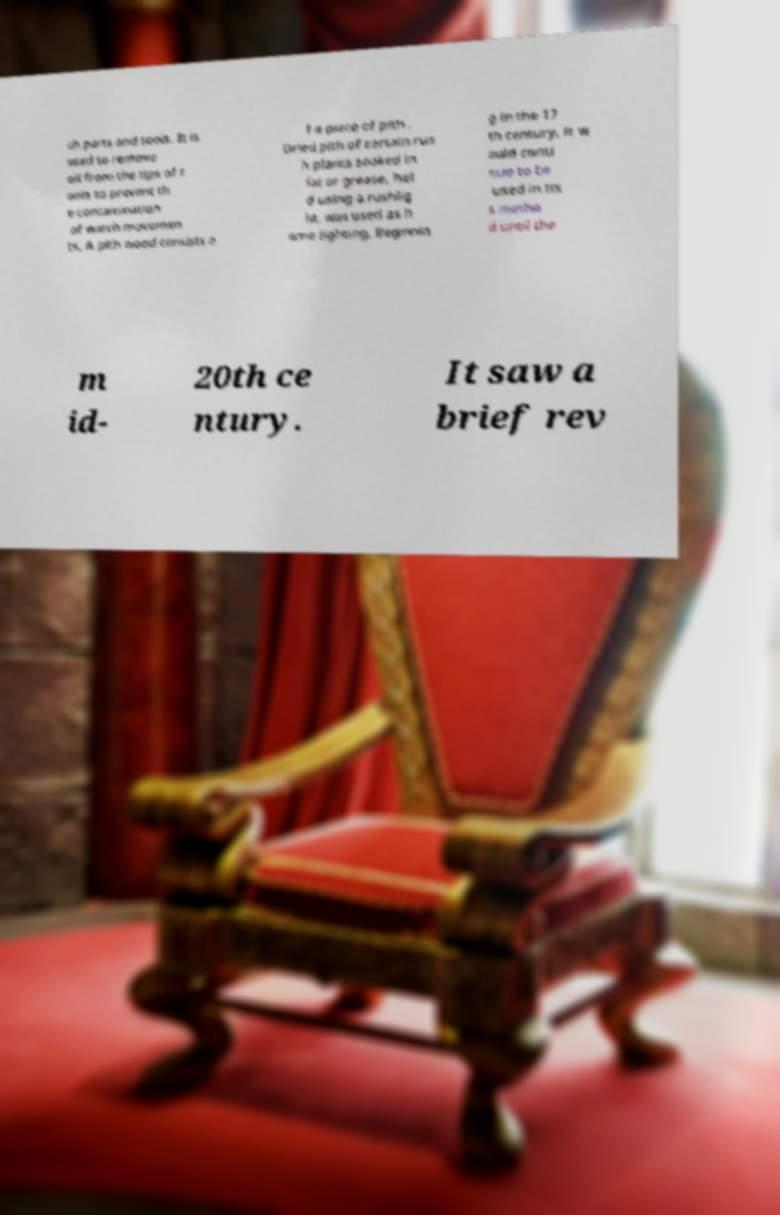For documentation purposes, I need the text within this image transcribed. Could you provide that? ch parts and tools. It is used to remove oil from the tips of t ools to prevent th e contamination of watch movemen ts. A pith wood consists o f a piece of pith . Dried pith of certain rus h plants soaked in fat or grease, hel d using a rushlig ht, was used as h ome lighting. Beginnin g in the 17 th century, it w ould conti nue to be used in thi s metho d until the m id- 20th ce ntury. It saw a brief rev 